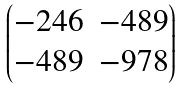Convert formula to latex. <formula><loc_0><loc_0><loc_500><loc_500>\begin{pmatrix} - 2 4 6 & - 4 8 9 \\ - 4 8 9 & - 9 7 8 \end{pmatrix}</formula> 